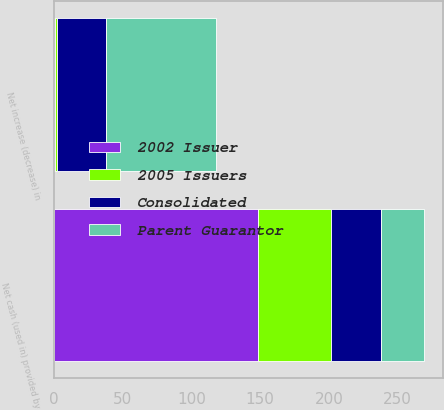Convert chart to OTSL. <chart><loc_0><loc_0><loc_500><loc_500><stacked_bar_chart><ecel><fcel>Net cash (used in) provided by<fcel>Net increase (decrease) in<nl><fcel>Parent Guarantor<fcel>31.6<fcel>80.1<nl><fcel>2002 Issuer<fcel>148.5<fcel>0.5<nl><fcel>2005 Issuers<fcel>53.2<fcel>1.3<nl><fcel>Consolidated<fcel>36.2<fcel>36.2<nl></chart> 